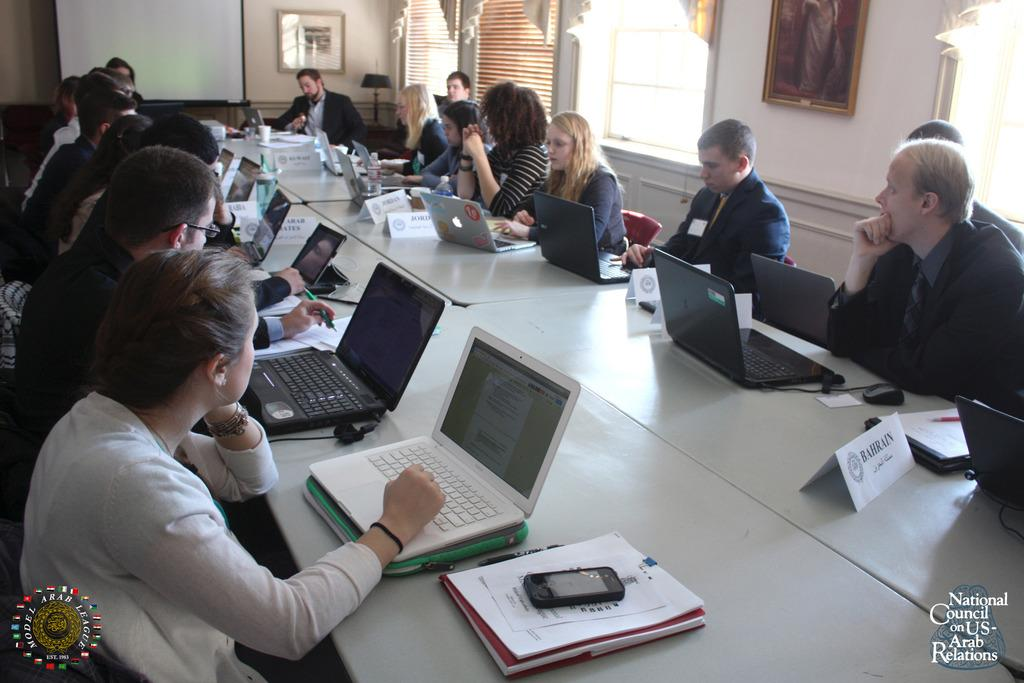<image>
Relay a brief, clear account of the picture shown. A meeting for National Council on US-Arab Relations. One nametag reads Bahrain. 